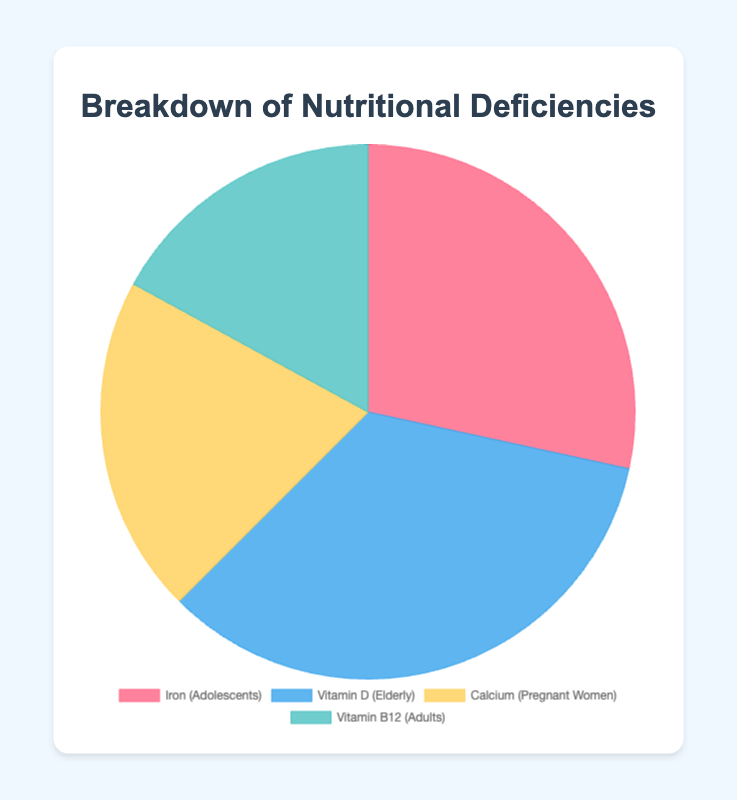What is the percentage of Vitamin D deficiency in the sample population? The chart displays the percentage of Vitamin D deficiency with each segment representing a different nutrient deficiency. The Vitamin D deficiency is represented by one segment in the pie chart labeled as "Vitamin D (Elderly)".
Answer: 30% Which nutrient has the highest deficiency percentage in the sample population? By visually inspecting the segments of the pie chart, we can compare the sizes and percentages of each segment. The largest segment is the one labeled "Vitamin D (Elderly)" with a 30% deficiency rate.
Answer: Vitamin D In the pie chart, what is the combined percentage of deficiencies for Iron and Calcium? Identify the percentages for Iron (25%) and Calcium (18%) from the chart. Add these two percentages together: 25% + 18% = 43%.
Answer: 43% Which nutrient deficiency is represented by the yellow color in the pie chart? The pie chart uses different colors to represent each nutrient. The segment colored in yellow is labeled as "Calcium (Pregnant Women)".
Answer: Calcium How does the iron deficiency percentage in adolescents compare to the vitamin B12 deficiency in adults? Examine the pie chart for the percentages of Iron and Vitamin B12 deficiencies, which are 25% and 15%, respectively. Compare these percentages: 25% > 15%.
Answer: Higher What is the difference between the deficiency percentages of Iron and Vitamin B12? From the chart, the percentage for Iron is 25%, and for Vitamin B12 it is 15%. Calculate the difference: 25% - 15% = 10%.
Answer: 10% Which nutrient deficiency affects the largest sample size in the study? The data provide sample sizes for each nutrient deficiency group. Vitamin B12 has the largest sample size of 2500 adults.
Answer: Vitamin B12 If you combine the deficiencies of Vitamin D and Vitamin B12, what would be the total percentage? Vitamin D deficiency is 30%, and Vitamin B12 is 15%. Adding these together gives 30% + 15% = 45%.
Answer: 45% What is the average percentage deficiency of the nutrients listed in the pie chart? Sum the percentages: 25% (Iron) + 30% (Vitamin D) + 18% (Calcium) + 15% (Vitamin B12) = 88%. The average is calculated as 88% / 4.
Answer: 22% Which nutrient deficiency has the smallest population sample, and what is its percentage? The smallest sample size listed in the data is for Pregnant Women (Calcium), with a sample size of 1000. The corresponding deficiency percentage is 18%.
Answer: Calcium, 18% 